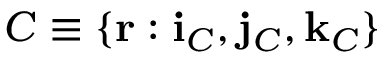Convert formula to latex. <formula><loc_0><loc_0><loc_500><loc_500>C \equiv \{ r \colon i _ { C } , j _ { C } , k _ { C } \}</formula> 